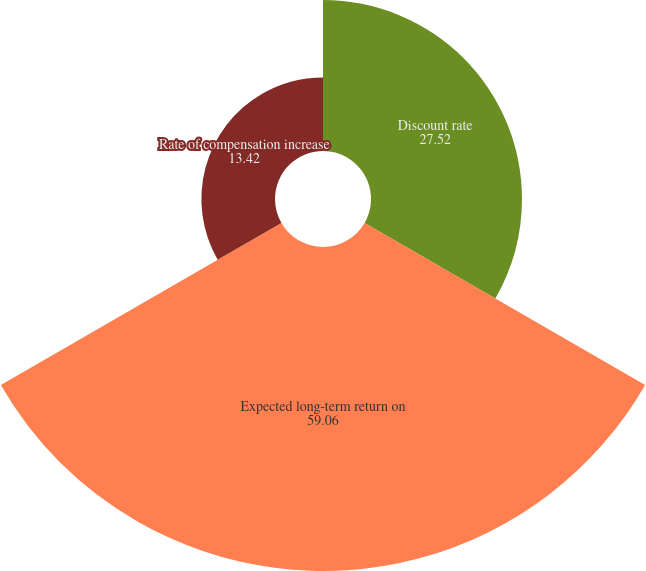Convert chart. <chart><loc_0><loc_0><loc_500><loc_500><pie_chart><fcel>Discount rate<fcel>Expected long-term return on<fcel>Rate of compensation increase<nl><fcel>27.52%<fcel>59.06%<fcel>13.42%<nl></chart> 